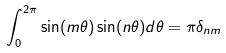<formula> <loc_0><loc_0><loc_500><loc_500>\int _ { 0 } ^ { 2 \pi } \sin ( m \theta ) \sin ( n \theta ) d \theta = \pi \delta _ { n m }</formula> 